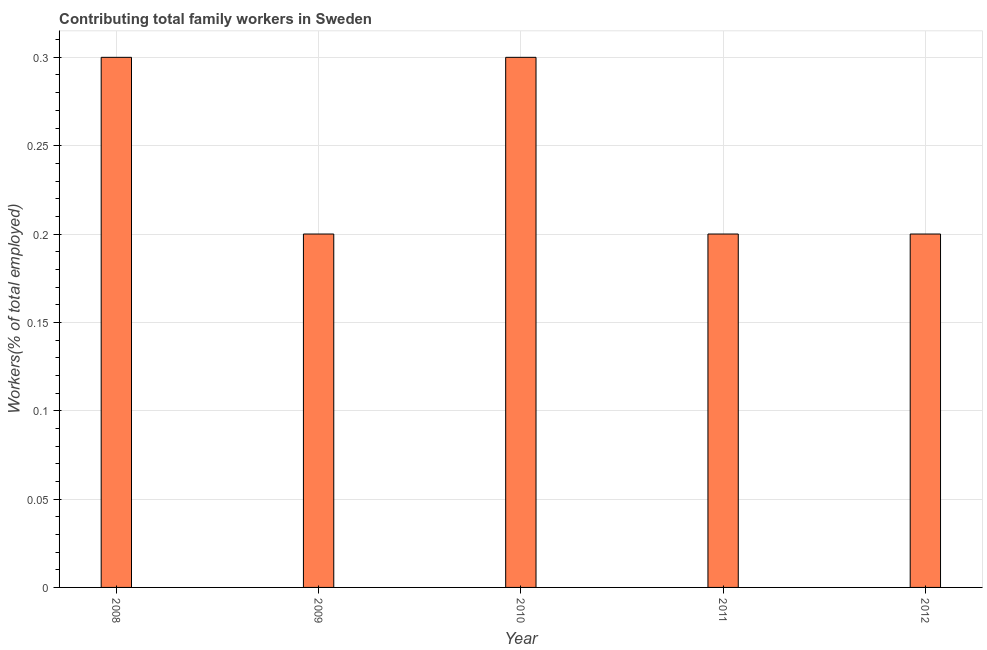Does the graph contain any zero values?
Keep it short and to the point. No. What is the title of the graph?
Make the answer very short. Contributing total family workers in Sweden. What is the label or title of the X-axis?
Make the answer very short. Year. What is the label or title of the Y-axis?
Your answer should be very brief. Workers(% of total employed). What is the contributing family workers in 2012?
Ensure brevity in your answer.  0.2. Across all years, what is the maximum contributing family workers?
Offer a terse response. 0.3. Across all years, what is the minimum contributing family workers?
Provide a succinct answer. 0.2. In which year was the contributing family workers maximum?
Give a very brief answer. 2008. What is the sum of the contributing family workers?
Offer a terse response. 1.2. What is the difference between the contributing family workers in 2009 and 2010?
Offer a very short reply. -0.1. What is the average contributing family workers per year?
Your answer should be compact. 0.24. What is the median contributing family workers?
Your answer should be compact. 0.2. Do a majority of the years between 2008 and 2010 (inclusive) have contributing family workers greater than 0.06 %?
Your answer should be compact. Yes. What is the ratio of the contributing family workers in 2009 to that in 2010?
Give a very brief answer. 0.67. What is the difference between the highest and the second highest contributing family workers?
Your answer should be very brief. 0. What is the difference between the highest and the lowest contributing family workers?
Your answer should be very brief. 0.1. How many bars are there?
Give a very brief answer. 5. Are all the bars in the graph horizontal?
Give a very brief answer. No. What is the Workers(% of total employed) in 2008?
Ensure brevity in your answer.  0.3. What is the Workers(% of total employed) in 2009?
Make the answer very short. 0.2. What is the Workers(% of total employed) in 2010?
Your response must be concise. 0.3. What is the Workers(% of total employed) of 2011?
Keep it short and to the point. 0.2. What is the Workers(% of total employed) in 2012?
Provide a succinct answer. 0.2. What is the difference between the Workers(% of total employed) in 2010 and 2011?
Your answer should be very brief. 0.1. What is the difference between the Workers(% of total employed) in 2010 and 2012?
Your answer should be very brief. 0.1. What is the difference between the Workers(% of total employed) in 2011 and 2012?
Your answer should be compact. 0. What is the ratio of the Workers(% of total employed) in 2008 to that in 2010?
Your answer should be compact. 1. What is the ratio of the Workers(% of total employed) in 2009 to that in 2010?
Offer a terse response. 0.67. What is the ratio of the Workers(% of total employed) in 2009 to that in 2012?
Make the answer very short. 1. What is the ratio of the Workers(% of total employed) in 2010 to that in 2011?
Offer a very short reply. 1.5. What is the ratio of the Workers(% of total employed) in 2011 to that in 2012?
Your response must be concise. 1. 